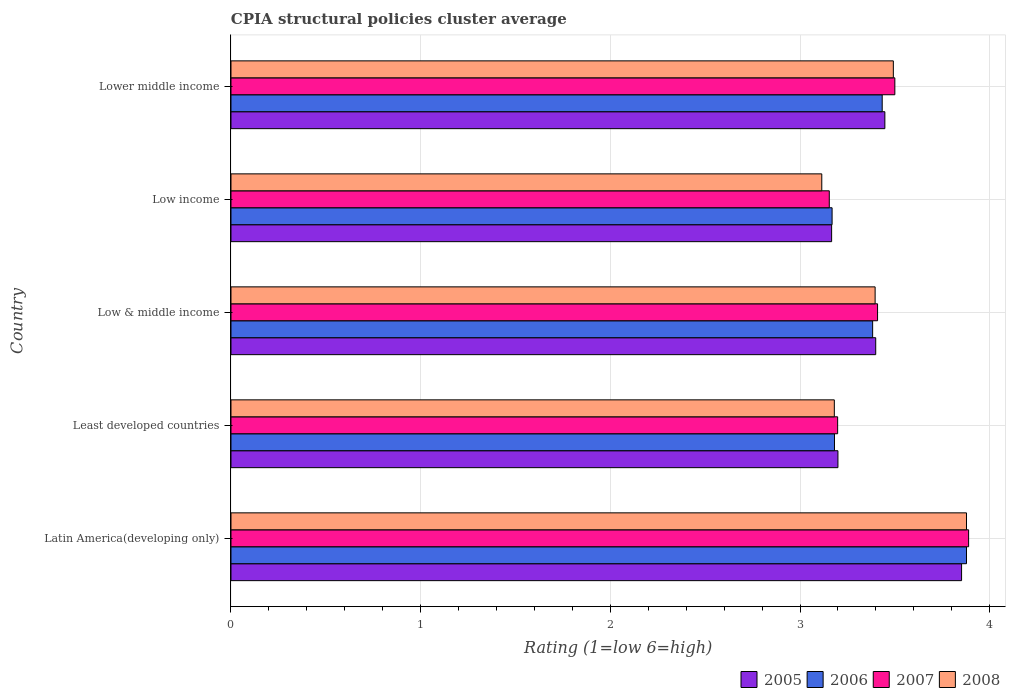How many different coloured bars are there?
Ensure brevity in your answer.  4. How many groups of bars are there?
Your answer should be compact. 5. How many bars are there on the 5th tick from the bottom?
Give a very brief answer. 4. What is the label of the 3rd group of bars from the top?
Ensure brevity in your answer.  Low & middle income. In how many cases, is the number of bars for a given country not equal to the number of legend labels?
Provide a succinct answer. 0. What is the CPIA rating in 2007 in Lower middle income?
Keep it short and to the point. 3.5. Across all countries, what is the maximum CPIA rating in 2007?
Provide a succinct answer. 3.89. Across all countries, what is the minimum CPIA rating in 2005?
Provide a succinct answer. 3.17. In which country was the CPIA rating in 2006 maximum?
Offer a very short reply. Latin America(developing only). What is the total CPIA rating in 2008 in the graph?
Ensure brevity in your answer.  17.06. What is the difference between the CPIA rating in 2005 in Low & middle income and that in Lower middle income?
Your answer should be very brief. -0.05. What is the difference between the CPIA rating in 2007 in Least developed countries and the CPIA rating in 2005 in Low & middle income?
Offer a terse response. -0.2. What is the average CPIA rating in 2006 per country?
Your response must be concise. 3.41. What is the difference between the CPIA rating in 2006 and CPIA rating in 2005 in Low income?
Provide a short and direct response. 0. In how many countries, is the CPIA rating in 2008 greater than 2 ?
Offer a very short reply. 5. What is the ratio of the CPIA rating in 2006 in Least developed countries to that in Low income?
Your answer should be very brief. 1. Is the CPIA rating in 2005 in Latin America(developing only) less than that in Low & middle income?
Your answer should be compact. No. Is the difference between the CPIA rating in 2006 in Least developed countries and Low & middle income greater than the difference between the CPIA rating in 2005 in Least developed countries and Low & middle income?
Give a very brief answer. No. What is the difference between the highest and the second highest CPIA rating in 2005?
Give a very brief answer. 0.4. What is the difference between the highest and the lowest CPIA rating in 2006?
Your answer should be very brief. 0.71. Is the sum of the CPIA rating in 2007 in Latin America(developing only) and Low income greater than the maximum CPIA rating in 2008 across all countries?
Offer a very short reply. Yes. What does the 4th bar from the top in Low & middle income represents?
Your answer should be very brief. 2005. What does the 1st bar from the bottom in Latin America(developing only) represents?
Provide a succinct answer. 2005. How many bars are there?
Your answer should be very brief. 20. What is the difference between two consecutive major ticks on the X-axis?
Your answer should be very brief. 1. Does the graph contain any zero values?
Give a very brief answer. No. How many legend labels are there?
Give a very brief answer. 4. How are the legend labels stacked?
Ensure brevity in your answer.  Horizontal. What is the title of the graph?
Your answer should be very brief. CPIA structural policies cluster average. What is the label or title of the X-axis?
Offer a terse response. Rating (1=low 6=high). What is the Rating (1=low 6=high) of 2005 in Latin America(developing only)?
Make the answer very short. 3.85. What is the Rating (1=low 6=high) of 2006 in Latin America(developing only)?
Offer a terse response. 3.88. What is the Rating (1=low 6=high) in 2007 in Latin America(developing only)?
Your response must be concise. 3.89. What is the Rating (1=low 6=high) in 2008 in Latin America(developing only)?
Provide a short and direct response. 3.88. What is the Rating (1=low 6=high) in 2006 in Least developed countries?
Your response must be concise. 3.18. What is the Rating (1=low 6=high) of 2007 in Least developed countries?
Make the answer very short. 3.2. What is the Rating (1=low 6=high) in 2008 in Least developed countries?
Keep it short and to the point. 3.18. What is the Rating (1=low 6=high) in 2005 in Low & middle income?
Ensure brevity in your answer.  3.4. What is the Rating (1=low 6=high) in 2006 in Low & middle income?
Your answer should be very brief. 3.38. What is the Rating (1=low 6=high) in 2007 in Low & middle income?
Your answer should be very brief. 3.41. What is the Rating (1=low 6=high) of 2008 in Low & middle income?
Ensure brevity in your answer.  3.4. What is the Rating (1=low 6=high) in 2005 in Low income?
Your response must be concise. 3.17. What is the Rating (1=low 6=high) of 2006 in Low income?
Make the answer very short. 3.17. What is the Rating (1=low 6=high) in 2007 in Low income?
Provide a succinct answer. 3.15. What is the Rating (1=low 6=high) of 2008 in Low income?
Offer a very short reply. 3.11. What is the Rating (1=low 6=high) of 2005 in Lower middle income?
Keep it short and to the point. 3.45. What is the Rating (1=low 6=high) in 2006 in Lower middle income?
Offer a very short reply. 3.43. What is the Rating (1=low 6=high) of 2008 in Lower middle income?
Your answer should be very brief. 3.49. Across all countries, what is the maximum Rating (1=low 6=high) of 2005?
Provide a short and direct response. 3.85. Across all countries, what is the maximum Rating (1=low 6=high) in 2006?
Your answer should be compact. 3.88. Across all countries, what is the maximum Rating (1=low 6=high) of 2007?
Your answer should be compact. 3.89. Across all countries, what is the maximum Rating (1=low 6=high) in 2008?
Provide a succinct answer. 3.88. Across all countries, what is the minimum Rating (1=low 6=high) in 2005?
Offer a terse response. 3.17. Across all countries, what is the minimum Rating (1=low 6=high) of 2006?
Your answer should be very brief. 3.17. Across all countries, what is the minimum Rating (1=low 6=high) of 2007?
Your response must be concise. 3.15. Across all countries, what is the minimum Rating (1=low 6=high) of 2008?
Offer a very short reply. 3.11. What is the total Rating (1=low 6=high) of 2005 in the graph?
Provide a succinct answer. 17.07. What is the total Rating (1=low 6=high) in 2006 in the graph?
Your answer should be very brief. 17.04. What is the total Rating (1=low 6=high) in 2007 in the graph?
Provide a short and direct response. 17.15. What is the total Rating (1=low 6=high) in 2008 in the graph?
Make the answer very short. 17.06. What is the difference between the Rating (1=low 6=high) in 2005 in Latin America(developing only) and that in Least developed countries?
Your answer should be very brief. 0.65. What is the difference between the Rating (1=low 6=high) of 2006 in Latin America(developing only) and that in Least developed countries?
Provide a short and direct response. 0.7. What is the difference between the Rating (1=low 6=high) in 2007 in Latin America(developing only) and that in Least developed countries?
Your answer should be compact. 0.69. What is the difference between the Rating (1=low 6=high) in 2008 in Latin America(developing only) and that in Least developed countries?
Provide a succinct answer. 0.7. What is the difference between the Rating (1=low 6=high) in 2005 in Latin America(developing only) and that in Low & middle income?
Your answer should be compact. 0.45. What is the difference between the Rating (1=low 6=high) of 2006 in Latin America(developing only) and that in Low & middle income?
Provide a succinct answer. 0.49. What is the difference between the Rating (1=low 6=high) in 2007 in Latin America(developing only) and that in Low & middle income?
Ensure brevity in your answer.  0.48. What is the difference between the Rating (1=low 6=high) of 2008 in Latin America(developing only) and that in Low & middle income?
Ensure brevity in your answer.  0.48. What is the difference between the Rating (1=low 6=high) of 2005 in Latin America(developing only) and that in Low income?
Your response must be concise. 0.69. What is the difference between the Rating (1=low 6=high) in 2006 in Latin America(developing only) and that in Low income?
Your answer should be compact. 0.71. What is the difference between the Rating (1=low 6=high) of 2007 in Latin America(developing only) and that in Low income?
Provide a succinct answer. 0.73. What is the difference between the Rating (1=low 6=high) in 2008 in Latin America(developing only) and that in Low income?
Offer a terse response. 0.76. What is the difference between the Rating (1=low 6=high) of 2005 in Latin America(developing only) and that in Lower middle income?
Your response must be concise. 0.4. What is the difference between the Rating (1=low 6=high) in 2006 in Latin America(developing only) and that in Lower middle income?
Ensure brevity in your answer.  0.44. What is the difference between the Rating (1=low 6=high) in 2007 in Latin America(developing only) and that in Lower middle income?
Your response must be concise. 0.39. What is the difference between the Rating (1=low 6=high) of 2008 in Latin America(developing only) and that in Lower middle income?
Ensure brevity in your answer.  0.39. What is the difference between the Rating (1=low 6=high) in 2005 in Least developed countries and that in Low & middle income?
Provide a short and direct response. -0.2. What is the difference between the Rating (1=low 6=high) of 2006 in Least developed countries and that in Low & middle income?
Your answer should be compact. -0.2. What is the difference between the Rating (1=low 6=high) in 2007 in Least developed countries and that in Low & middle income?
Make the answer very short. -0.21. What is the difference between the Rating (1=low 6=high) of 2008 in Least developed countries and that in Low & middle income?
Your response must be concise. -0.21. What is the difference between the Rating (1=low 6=high) in 2006 in Least developed countries and that in Low income?
Provide a succinct answer. 0.01. What is the difference between the Rating (1=low 6=high) of 2007 in Least developed countries and that in Low income?
Your answer should be compact. 0.04. What is the difference between the Rating (1=low 6=high) of 2008 in Least developed countries and that in Low income?
Your answer should be very brief. 0.07. What is the difference between the Rating (1=low 6=high) of 2005 in Least developed countries and that in Lower middle income?
Your response must be concise. -0.25. What is the difference between the Rating (1=low 6=high) of 2006 in Least developed countries and that in Lower middle income?
Your response must be concise. -0.25. What is the difference between the Rating (1=low 6=high) of 2007 in Least developed countries and that in Lower middle income?
Your response must be concise. -0.3. What is the difference between the Rating (1=low 6=high) in 2008 in Least developed countries and that in Lower middle income?
Make the answer very short. -0.31. What is the difference between the Rating (1=low 6=high) of 2005 in Low & middle income and that in Low income?
Provide a short and direct response. 0.23. What is the difference between the Rating (1=low 6=high) in 2006 in Low & middle income and that in Low income?
Offer a terse response. 0.21. What is the difference between the Rating (1=low 6=high) in 2007 in Low & middle income and that in Low income?
Keep it short and to the point. 0.25. What is the difference between the Rating (1=low 6=high) in 2008 in Low & middle income and that in Low income?
Your response must be concise. 0.28. What is the difference between the Rating (1=low 6=high) in 2005 in Low & middle income and that in Lower middle income?
Your answer should be compact. -0.05. What is the difference between the Rating (1=low 6=high) of 2006 in Low & middle income and that in Lower middle income?
Provide a succinct answer. -0.05. What is the difference between the Rating (1=low 6=high) of 2007 in Low & middle income and that in Lower middle income?
Offer a very short reply. -0.09. What is the difference between the Rating (1=low 6=high) of 2008 in Low & middle income and that in Lower middle income?
Provide a succinct answer. -0.1. What is the difference between the Rating (1=low 6=high) of 2005 in Low income and that in Lower middle income?
Give a very brief answer. -0.28. What is the difference between the Rating (1=low 6=high) in 2006 in Low income and that in Lower middle income?
Give a very brief answer. -0.26. What is the difference between the Rating (1=low 6=high) in 2007 in Low income and that in Lower middle income?
Your response must be concise. -0.35. What is the difference between the Rating (1=low 6=high) in 2008 in Low income and that in Lower middle income?
Provide a succinct answer. -0.38. What is the difference between the Rating (1=low 6=high) in 2005 in Latin America(developing only) and the Rating (1=low 6=high) in 2006 in Least developed countries?
Offer a terse response. 0.67. What is the difference between the Rating (1=low 6=high) of 2005 in Latin America(developing only) and the Rating (1=low 6=high) of 2007 in Least developed countries?
Provide a succinct answer. 0.65. What is the difference between the Rating (1=low 6=high) in 2005 in Latin America(developing only) and the Rating (1=low 6=high) in 2008 in Least developed countries?
Offer a terse response. 0.67. What is the difference between the Rating (1=low 6=high) of 2006 in Latin America(developing only) and the Rating (1=low 6=high) of 2007 in Least developed countries?
Your answer should be compact. 0.68. What is the difference between the Rating (1=low 6=high) of 2006 in Latin America(developing only) and the Rating (1=low 6=high) of 2008 in Least developed countries?
Your response must be concise. 0.7. What is the difference between the Rating (1=low 6=high) in 2007 in Latin America(developing only) and the Rating (1=low 6=high) in 2008 in Least developed countries?
Give a very brief answer. 0.71. What is the difference between the Rating (1=low 6=high) in 2005 in Latin America(developing only) and the Rating (1=low 6=high) in 2006 in Low & middle income?
Offer a terse response. 0.47. What is the difference between the Rating (1=low 6=high) of 2005 in Latin America(developing only) and the Rating (1=low 6=high) of 2007 in Low & middle income?
Your answer should be very brief. 0.44. What is the difference between the Rating (1=low 6=high) in 2005 in Latin America(developing only) and the Rating (1=low 6=high) in 2008 in Low & middle income?
Make the answer very short. 0.46. What is the difference between the Rating (1=low 6=high) in 2006 in Latin America(developing only) and the Rating (1=low 6=high) in 2007 in Low & middle income?
Ensure brevity in your answer.  0.47. What is the difference between the Rating (1=low 6=high) of 2006 in Latin America(developing only) and the Rating (1=low 6=high) of 2008 in Low & middle income?
Your response must be concise. 0.48. What is the difference between the Rating (1=low 6=high) in 2007 in Latin America(developing only) and the Rating (1=low 6=high) in 2008 in Low & middle income?
Give a very brief answer. 0.49. What is the difference between the Rating (1=low 6=high) of 2005 in Latin America(developing only) and the Rating (1=low 6=high) of 2006 in Low income?
Make the answer very short. 0.68. What is the difference between the Rating (1=low 6=high) in 2005 in Latin America(developing only) and the Rating (1=low 6=high) in 2007 in Low income?
Ensure brevity in your answer.  0.7. What is the difference between the Rating (1=low 6=high) of 2005 in Latin America(developing only) and the Rating (1=low 6=high) of 2008 in Low income?
Offer a very short reply. 0.74. What is the difference between the Rating (1=low 6=high) of 2006 in Latin America(developing only) and the Rating (1=low 6=high) of 2007 in Low income?
Offer a very short reply. 0.72. What is the difference between the Rating (1=low 6=high) of 2006 in Latin America(developing only) and the Rating (1=low 6=high) of 2008 in Low income?
Keep it short and to the point. 0.76. What is the difference between the Rating (1=low 6=high) of 2007 in Latin America(developing only) and the Rating (1=low 6=high) of 2008 in Low income?
Give a very brief answer. 0.77. What is the difference between the Rating (1=low 6=high) in 2005 in Latin America(developing only) and the Rating (1=low 6=high) in 2006 in Lower middle income?
Your answer should be very brief. 0.42. What is the difference between the Rating (1=low 6=high) in 2005 in Latin America(developing only) and the Rating (1=low 6=high) in 2007 in Lower middle income?
Give a very brief answer. 0.35. What is the difference between the Rating (1=low 6=high) of 2005 in Latin America(developing only) and the Rating (1=low 6=high) of 2008 in Lower middle income?
Give a very brief answer. 0.36. What is the difference between the Rating (1=low 6=high) in 2006 in Latin America(developing only) and the Rating (1=low 6=high) in 2007 in Lower middle income?
Your response must be concise. 0.38. What is the difference between the Rating (1=low 6=high) in 2006 in Latin America(developing only) and the Rating (1=low 6=high) in 2008 in Lower middle income?
Ensure brevity in your answer.  0.39. What is the difference between the Rating (1=low 6=high) of 2007 in Latin America(developing only) and the Rating (1=low 6=high) of 2008 in Lower middle income?
Ensure brevity in your answer.  0.4. What is the difference between the Rating (1=low 6=high) of 2005 in Least developed countries and the Rating (1=low 6=high) of 2006 in Low & middle income?
Offer a terse response. -0.18. What is the difference between the Rating (1=low 6=high) in 2005 in Least developed countries and the Rating (1=low 6=high) in 2007 in Low & middle income?
Your answer should be compact. -0.21. What is the difference between the Rating (1=low 6=high) of 2005 in Least developed countries and the Rating (1=low 6=high) of 2008 in Low & middle income?
Offer a very short reply. -0.2. What is the difference between the Rating (1=low 6=high) of 2006 in Least developed countries and the Rating (1=low 6=high) of 2007 in Low & middle income?
Provide a succinct answer. -0.23. What is the difference between the Rating (1=low 6=high) in 2006 in Least developed countries and the Rating (1=low 6=high) in 2008 in Low & middle income?
Your answer should be very brief. -0.21. What is the difference between the Rating (1=low 6=high) of 2007 in Least developed countries and the Rating (1=low 6=high) of 2008 in Low & middle income?
Provide a short and direct response. -0.2. What is the difference between the Rating (1=low 6=high) of 2005 in Least developed countries and the Rating (1=low 6=high) of 2006 in Low income?
Your answer should be compact. 0.03. What is the difference between the Rating (1=low 6=high) of 2005 in Least developed countries and the Rating (1=low 6=high) of 2007 in Low income?
Keep it short and to the point. 0.05. What is the difference between the Rating (1=low 6=high) of 2005 in Least developed countries and the Rating (1=low 6=high) of 2008 in Low income?
Your answer should be compact. 0.09. What is the difference between the Rating (1=low 6=high) in 2006 in Least developed countries and the Rating (1=low 6=high) in 2007 in Low income?
Your response must be concise. 0.03. What is the difference between the Rating (1=low 6=high) in 2006 in Least developed countries and the Rating (1=low 6=high) in 2008 in Low income?
Ensure brevity in your answer.  0.07. What is the difference between the Rating (1=low 6=high) of 2007 in Least developed countries and the Rating (1=low 6=high) of 2008 in Low income?
Offer a very short reply. 0.08. What is the difference between the Rating (1=low 6=high) of 2005 in Least developed countries and the Rating (1=low 6=high) of 2006 in Lower middle income?
Your response must be concise. -0.23. What is the difference between the Rating (1=low 6=high) in 2005 in Least developed countries and the Rating (1=low 6=high) in 2007 in Lower middle income?
Ensure brevity in your answer.  -0.3. What is the difference between the Rating (1=low 6=high) of 2005 in Least developed countries and the Rating (1=low 6=high) of 2008 in Lower middle income?
Make the answer very short. -0.29. What is the difference between the Rating (1=low 6=high) in 2006 in Least developed countries and the Rating (1=low 6=high) in 2007 in Lower middle income?
Offer a very short reply. -0.32. What is the difference between the Rating (1=low 6=high) of 2006 in Least developed countries and the Rating (1=low 6=high) of 2008 in Lower middle income?
Keep it short and to the point. -0.31. What is the difference between the Rating (1=low 6=high) of 2007 in Least developed countries and the Rating (1=low 6=high) of 2008 in Lower middle income?
Offer a very short reply. -0.29. What is the difference between the Rating (1=low 6=high) of 2005 in Low & middle income and the Rating (1=low 6=high) of 2006 in Low income?
Provide a short and direct response. 0.23. What is the difference between the Rating (1=low 6=high) in 2005 in Low & middle income and the Rating (1=low 6=high) in 2007 in Low income?
Your answer should be very brief. 0.24. What is the difference between the Rating (1=low 6=high) of 2005 in Low & middle income and the Rating (1=low 6=high) of 2008 in Low income?
Provide a succinct answer. 0.28. What is the difference between the Rating (1=low 6=high) of 2006 in Low & middle income and the Rating (1=low 6=high) of 2007 in Low income?
Provide a short and direct response. 0.23. What is the difference between the Rating (1=low 6=high) of 2006 in Low & middle income and the Rating (1=low 6=high) of 2008 in Low income?
Offer a terse response. 0.27. What is the difference between the Rating (1=low 6=high) of 2007 in Low & middle income and the Rating (1=low 6=high) of 2008 in Low income?
Provide a short and direct response. 0.29. What is the difference between the Rating (1=low 6=high) of 2005 in Low & middle income and the Rating (1=low 6=high) of 2006 in Lower middle income?
Provide a short and direct response. -0.03. What is the difference between the Rating (1=low 6=high) of 2005 in Low & middle income and the Rating (1=low 6=high) of 2007 in Lower middle income?
Offer a very short reply. -0.1. What is the difference between the Rating (1=low 6=high) of 2005 in Low & middle income and the Rating (1=low 6=high) of 2008 in Lower middle income?
Ensure brevity in your answer.  -0.09. What is the difference between the Rating (1=low 6=high) of 2006 in Low & middle income and the Rating (1=low 6=high) of 2007 in Lower middle income?
Keep it short and to the point. -0.12. What is the difference between the Rating (1=low 6=high) of 2006 in Low & middle income and the Rating (1=low 6=high) of 2008 in Lower middle income?
Your answer should be very brief. -0.11. What is the difference between the Rating (1=low 6=high) of 2007 in Low & middle income and the Rating (1=low 6=high) of 2008 in Lower middle income?
Offer a very short reply. -0.08. What is the difference between the Rating (1=low 6=high) of 2005 in Low income and the Rating (1=low 6=high) of 2006 in Lower middle income?
Offer a very short reply. -0.27. What is the difference between the Rating (1=low 6=high) of 2005 in Low income and the Rating (1=low 6=high) of 2007 in Lower middle income?
Your answer should be compact. -0.33. What is the difference between the Rating (1=low 6=high) in 2005 in Low income and the Rating (1=low 6=high) in 2008 in Lower middle income?
Your answer should be very brief. -0.33. What is the difference between the Rating (1=low 6=high) in 2006 in Low income and the Rating (1=low 6=high) in 2007 in Lower middle income?
Give a very brief answer. -0.33. What is the difference between the Rating (1=low 6=high) of 2006 in Low income and the Rating (1=low 6=high) of 2008 in Lower middle income?
Make the answer very short. -0.32. What is the difference between the Rating (1=low 6=high) in 2007 in Low income and the Rating (1=low 6=high) in 2008 in Lower middle income?
Provide a short and direct response. -0.34. What is the average Rating (1=low 6=high) in 2005 per country?
Give a very brief answer. 3.41. What is the average Rating (1=low 6=high) of 2006 per country?
Keep it short and to the point. 3.41. What is the average Rating (1=low 6=high) in 2007 per country?
Ensure brevity in your answer.  3.43. What is the average Rating (1=low 6=high) in 2008 per country?
Keep it short and to the point. 3.41. What is the difference between the Rating (1=low 6=high) in 2005 and Rating (1=low 6=high) in 2006 in Latin America(developing only)?
Your response must be concise. -0.03. What is the difference between the Rating (1=low 6=high) in 2005 and Rating (1=low 6=high) in 2007 in Latin America(developing only)?
Your answer should be very brief. -0.04. What is the difference between the Rating (1=low 6=high) of 2005 and Rating (1=low 6=high) of 2008 in Latin America(developing only)?
Your answer should be compact. -0.03. What is the difference between the Rating (1=low 6=high) of 2006 and Rating (1=low 6=high) of 2007 in Latin America(developing only)?
Provide a succinct answer. -0.01. What is the difference between the Rating (1=low 6=high) in 2007 and Rating (1=low 6=high) in 2008 in Latin America(developing only)?
Keep it short and to the point. 0.01. What is the difference between the Rating (1=low 6=high) of 2005 and Rating (1=low 6=high) of 2006 in Least developed countries?
Offer a terse response. 0.02. What is the difference between the Rating (1=low 6=high) in 2005 and Rating (1=low 6=high) in 2007 in Least developed countries?
Offer a very short reply. 0. What is the difference between the Rating (1=low 6=high) of 2005 and Rating (1=low 6=high) of 2008 in Least developed countries?
Ensure brevity in your answer.  0.02. What is the difference between the Rating (1=low 6=high) in 2006 and Rating (1=low 6=high) in 2007 in Least developed countries?
Offer a very short reply. -0.02. What is the difference between the Rating (1=low 6=high) in 2006 and Rating (1=low 6=high) in 2008 in Least developed countries?
Give a very brief answer. 0. What is the difference between the Rating (1=low 6=high) in 2007 and Rating (1=low 6=high) in 2008 in Least developed countries?
Your response must be concise. 0.02. What is the difference between the Rating (1=low 6=high) of 2005 and Rating (1=low 6=high) of 2006 in Low & middle income?
Give a very brief answer. 0.02. What is the difference between the Rating (1=low 6=high) of 2005 and Rating (1=low 6=high) of 2007 in Low & middle income?
Give a very brief answer. -0.01. What is the difference between the Rating (1=low 6=high) of 2005 and Rating (1=low 6=high) of 2008 in Low & middle income?
Your answer should be very brief. 0. What is the difference between the Rating (1=low 6=high) in 2006 and Rating (1=low 6=high) in 2007 in Low & middle income?
Your response must be concise. -0.03. What is the difference between the Rating (1=low 6=high) of 2006 and Rating (1=low 6=high) of 2008 in Low & middle income?
Provide a short and direct response. -0.01. What is the difference between the Rating (1=low 6=high) of 2007 and Rating (1=low 6=high) of 2008 in Low & middle income?
Your response must be concise. 0.01. What is the difference between the Rating (1=low 6=high) of 2005 and Rating (1=low 6=high) of 2006 in Low income?
Give a very brief answer. -0. What is the difference between the Rating (1=low 6=high) in 2005 and Rating (1=low 6=high) in 2007 in Low income?
Make the answer very short. 0.01. What is the difference between the Rating (1=low 6=high) of 2005 and Rating (1=low 6=high) of 2008 in Low income?
Make the answer very short. 0.05. What is the difference between the Rating (1=low 6=high) of 2006 and Rating (1=low 6=high) of 2007 in Low income?
Provide a succinct answer. 0.01. What is the difference between the Rating (1=low 6=high) in 2006 and Rating (1=low 6=high) in 2008 in Low income?
Your answer should be compact. 0.05. What is the difference between the Rating (1=low 6=high) in 2007 and Rating (1=low 6=high) in 2008 in Low income?
Make the answer very short. 0.04. What is the difference between the Rating (1=low 6=high) of 2005 and Rating (1=low 6=high) of 2006 in Lower middle income?
Give a very brief answer. 0.01. What is the difference between the Rating (1=low 6=high) in 2005 and Rating (1=low 6=high) in 2007 in Lower middle income?
Ensure brevity in your answer.  -0.05. What is the difference between the Rating (1=low 6=high) in 2005 and Rating (1=low 6=high) in 2008 in Lower middle income?
Offer a terse response. -0.04. What is the difference between the Rating (1=low 6=high) in 2006 and Rating (1=low 6=high) in 2007 in Lower middle income?
Offer a terse response. -0.07. What is the difference between the Rating (1=low 6=high) in 2006 and Rating (1=low 6=high) in 2008 in Lower middle income?
Make the answer very short. -0.06. What is the difference between the Rating (1=low 6=high) of 2007 and Rating (1=low 6=high) of 2008 in Lower middle income?
Your response must be concise. 0.01. What is the ratio of the Rating (1=low 6=high) of 2005 in Latin America(developing only) to that in Least developed countries?
Make the answer very short. 1.2. What is the ratio of the Rating (1=low 6=high) in 2006 in Latin America(developing only) to that in Least developed countries?
Offer a very short reply. 1.22. What is the ratio of the Rating (1=low 6=high) of 2007 in Latin America(developing only) to that in Least developed countries?
Make the answer very short. 1.22. What is the ratio of the Rating (1=low 6=high) of 2008 in Latin America(developing only) to that in Least developed countries?
Offer a very short reply. 1.22. What is the ratio of the Rating (1=low 6=high) of 2005 in Latin America(developing only) to that in Low & middle income?
Your answer should be compact. 1.13. What is the ratio of the Rating (1=low 6=high) in 2006 in Latin America(developing only) to that in Low & middle income?
Your response must be concise. 1.15. What is the ratio of the Rating (1=low 6=high) of 2007 in Latin America(developing only) to that in Low & middle income?
Provide a succinct answer. 1.14. What is the ratio of the Rating (1=low 6=high) of 2008 in Latin America(developing only) to that in Low & middle income?
Keep it short and to the point. 1.14. What is the ratio of the Rating (1=low 6=high) of 2005 in Latin America(developing only) to that in Low income?
Offer a very short reply. 1.22. What is the ratio of the Rating (1=low 6=high) of 2006 in Latin America(developing only) to that in Low income?
Offer a terse response. 1.22. What is the ratio of the Rating (1=low 6=high) in 2007 in Latin America(developing only) to that in Low income?
Provide a short and direct response. 1.23. What is the ratio of the Rating (1=low 6=high) in 2008 in Latin America(developing only) to that in Low income?
Keep it short and to the point. 1.24. What is the ratio of the Rating (1=low 6=high) of 2005 in Latin America(developing only) to that in Lower middle income?
Keep it short and to the point. 1.12. What is the ratio of the Rating (1=low 6=high) in 2006 in Latin America(developing only) to that in Lower middle income?
Your response must be concise. 1.13. What is the ratio of the Rating (1=low 6=high) of 2008 in Latin America(developing only) to that in Lower middle income?
Offer a very short reply. 1.11. What is the ratio of the Rating (1=low 6=high) of 2005 in Least developed countries to that in Low & middle income?
Provide a short and direct response. 0.94. What is the ratio of the Rating (1=low 6=high) in 2006 in Least developed countries to that in Low & middle income?
Provide a succinct answer. 0.94. What is the ratio of the Rating (1=low 6=high) in 2007 in Least developed countries to that in Low & middle income?
Offer a very short reply. 0.94. What is the ratio of the Rating (1=low 6=high) of 2008 in Least developed countries to that in Low & middle income?
Your response must be concise. 0.94. What is the ratio of the Rating (1=low 6=high) of 2005 in Least developed countries to that in Low income?
Your answer should be very brief. 1.01. What is the ratio of the Rating (1=low 6=high) of 2007 in Least developed countries to that in Low income?
Your response must be concise. 1.01. What is the ratio of the Rating (1=low 6=high) of 2008 in Least developed countries to that in Low income?
Provide a short and direct response. 1.02. What is the ratio of the Rating (1=low 6=high) of 2005 in Least developed countries to that in Lower middle income?
Provide a succinct answer. 0.93. What is the ratio of the Rating (1=low 6=high) in 2006 in Least developed countries to that in Lower middle income?
Offer a very short reply. 0.93. What is the ratio of the Rating (1=low 6=high) of 2007 in Least developed countries to that in Lower middle income?
Offer a terse response. 0.91. What is the ratio of the Rating (1=low 6=high) in 2008 in Least developed countries to that in Lower middle income?
Provide a short and direct response. 0.91. What is the ratio of the Rating (1=low 6=high) in 2005 in Low & middle income to that in Low income?
Provide a short and direct response. 1.07. What is the ratio of the Rating (1=low 6=high) in 2006 in Low & middle income to that in Low income?
Keep it short and to the point. 1.07. What is the ratio of the Rating (1=low 6=high) of 2007 in Low & middle income to that in Low income?
Provide a short and direct response. 1.08. What is the ratio of the Rating (1=low 6=high) in 2008 in Low & middle income to that in Low income?
Provide a succinct answer. 1.09. What is the ratio of the Rating (1=low 6=high) in 2005 in Low & middle income to that in Lower middle income?
Your answer should be compact. 0.99. What is the ratio of the Rating (1=low 6=high) of 2006 in Low & middle income to that in Lower middle income?
Provide a succinct answer. 0.99. What is the ratio of the Rating (1=low 6=high) of 2008 in Low & middle income to that in Lower middle income?
Provide a short and direct response. 0.97. What is the ratio of the Rating (1=low 6=high) of 2005 in Low income to that in Lower middle income?
Provide a short and direct response. 0.92. What is the ratio of the Rating (1=low 6=high) of 2006 in Low income to that in Lower middle income?
Ensure brevity in your answer.  0.92. What is the ratio of the Rating (1=low 6=high) of 2007 in Low income to that in Lower middle income?
Offer a terse response. 0.9. What is the ratio of the Rating (1=low 6=high) of 2008 in Low income to that in Lower middle income?
Provide a short and direct response. 0.89. What is the difference between the highest and the second highest Rating (1=low 6=high) of 2005?
Keep it short and to the point. 0.4. What is the difference between the highest and the second highest Rating (1=low 6=high) in 2006?
Your answer should be compact. 0.44. What is the difference between the highest and the second highest Rating (1=low 6=high) in 2007?
Keep it short and to the point. 0.39. What is the difference between the highest and the second highest Rating (1=low 6=high) of 2008?
Offer a terse response. 0.39. What is the difference between the highest and the lowest Rating (1=low 6=high) of 2005?
Your answer should be very brief. 0.69. What is the difference between the highest and the lowest Rating (1=low 6=high) in 2006?
Keep it short and to the point. 0.71. What is the difference between the highest and the lowest Rating (1=low 6=high) of 2007?
Keep it short and to the point. 0.73. What is the difference between the highest and the lowest Rating (1=low 6=high) in 2008?
Provide a succinct answer. 0.76. 